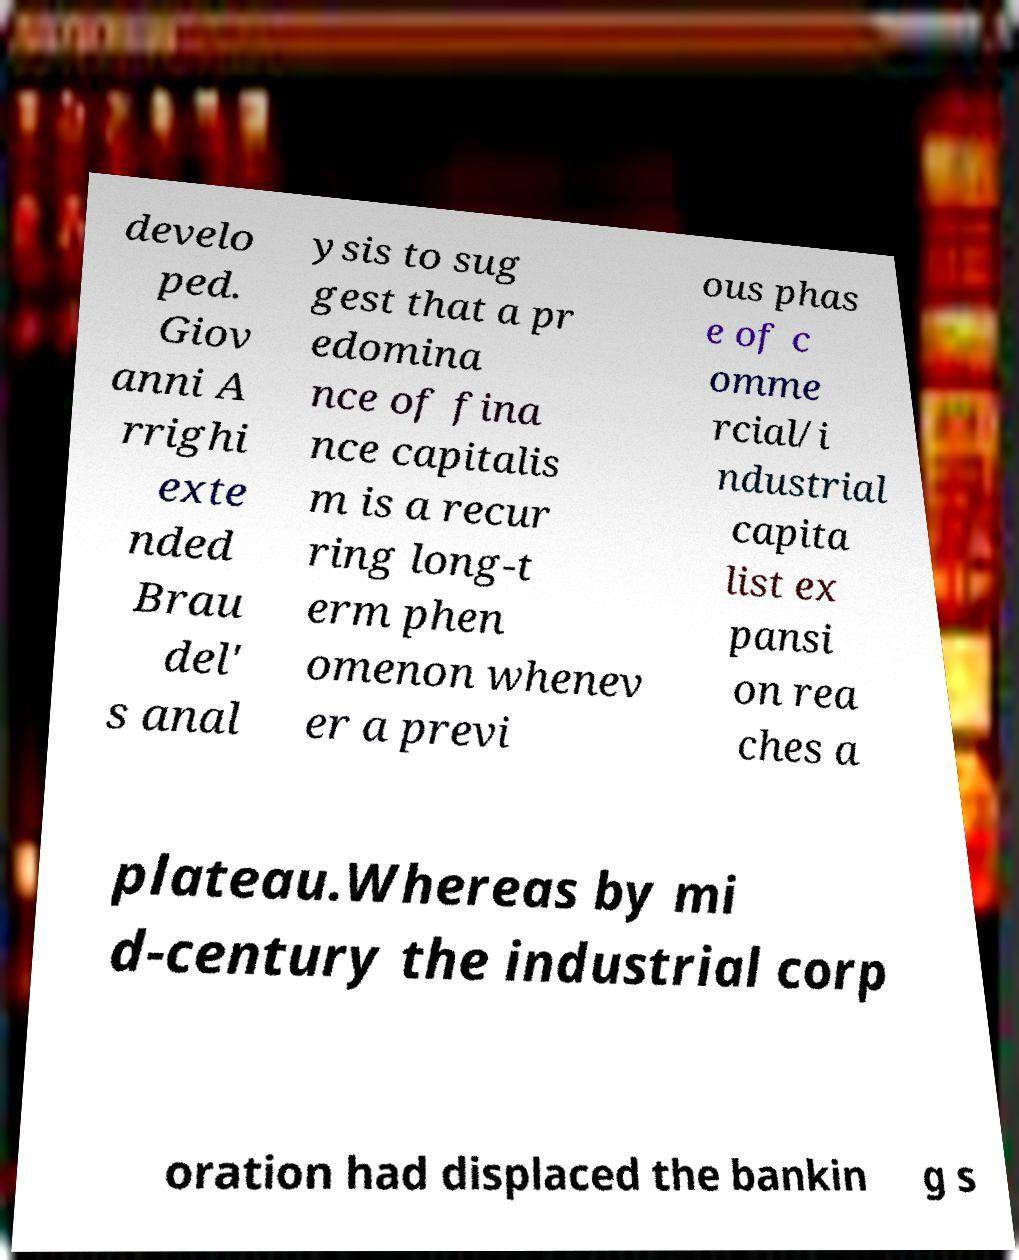Can you read and provide the text displayed in the image?This photo seems to have some interesting text. Can you extract and type it out for me? develo ped. Giov anni A rrighi exte nded Brau del' s anal ysis to sug gest that a pr edomina nce of fina nce capitalis m is a recur ring long-t erm phen omenon whenev er a previ ous phas e of c omme rcial/i ndustrial capita list ex pansi on rea ches a plateau.Whereas by mi d-century the industrial corp oration had displaced the bankin g s 